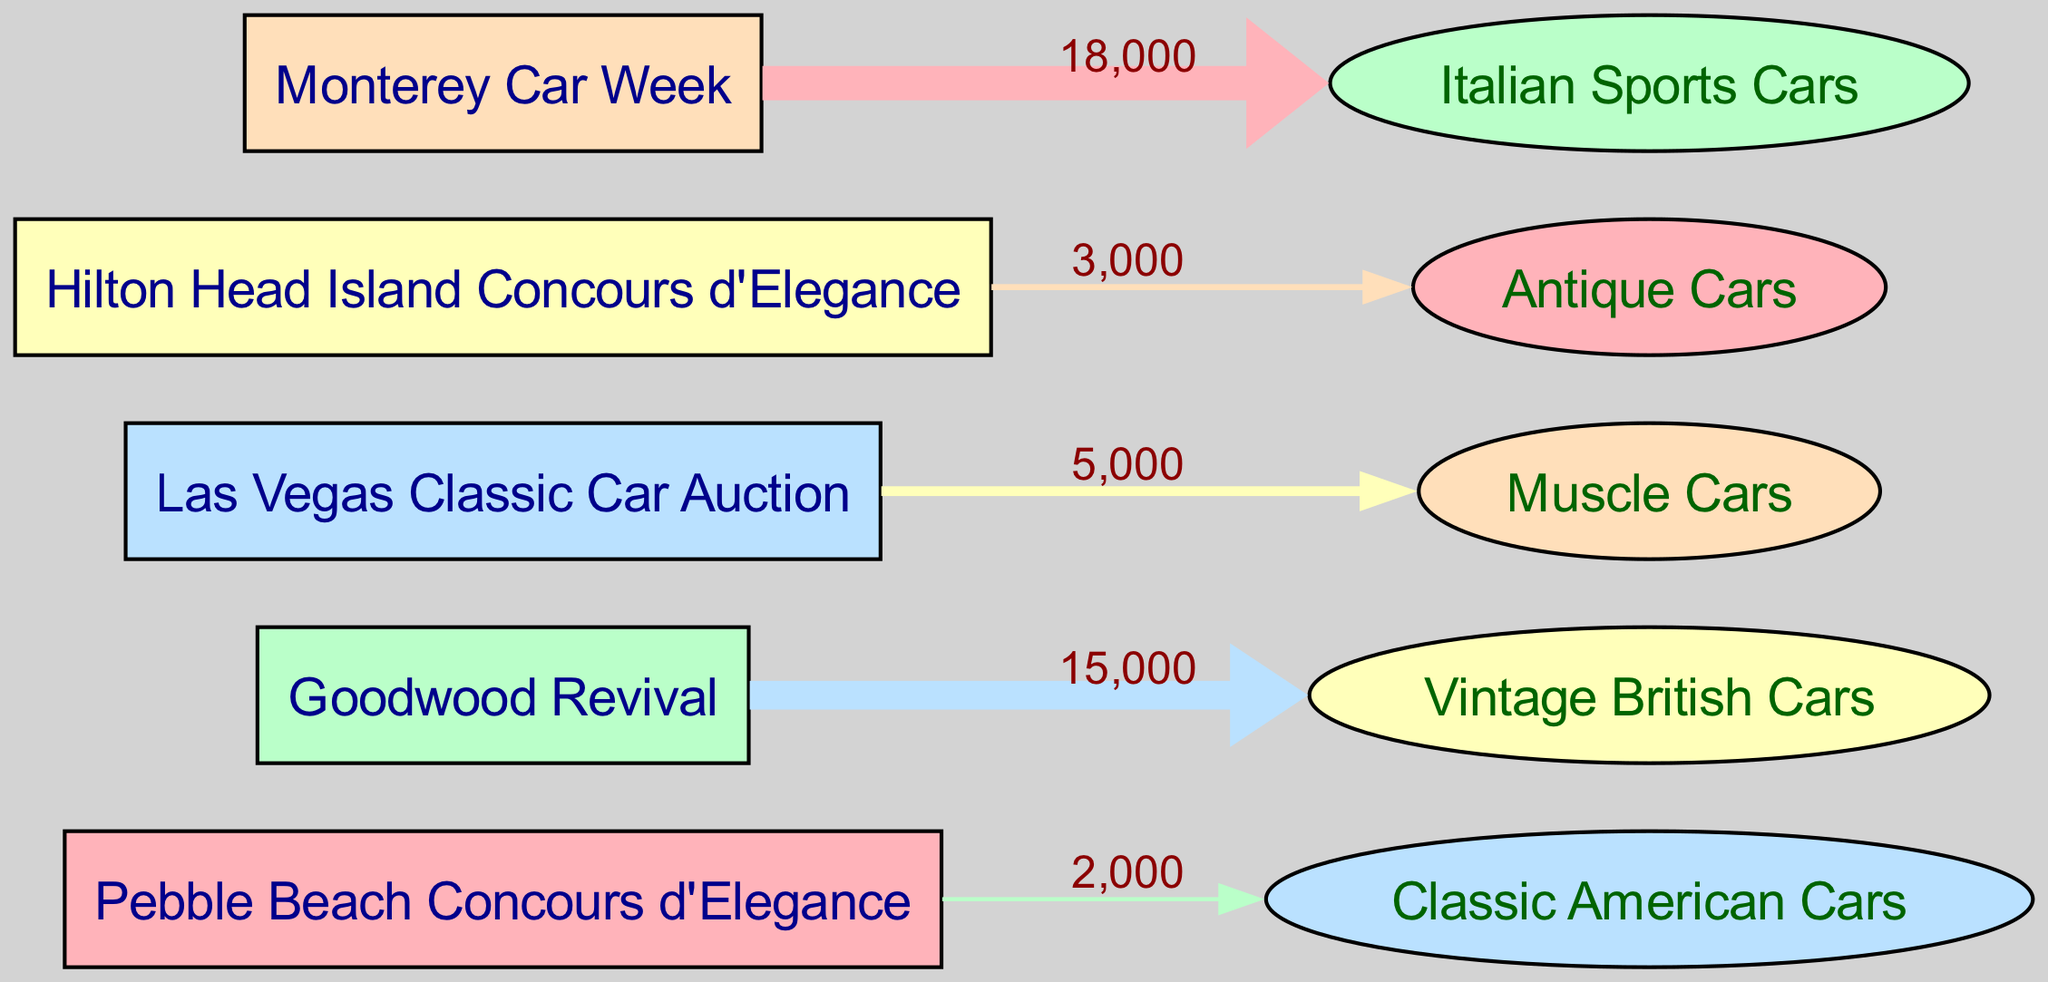What is the location with the highest visitor count? The diagram shows various car show locations and their corresponding visitor counts. By checking the flow from each location, the highest visitor count can be identified easily. In this case, "Monterey Car Week" has the highest visitor count of 18000.
Answer: Monterey Car Week How many vehicle types are represented in the diagram? The diagram includes various vehicle types connected to their respective locations. By counting the unique vehicle types shown in the diagram, we can find that there are five distinct vehicle types.
Answer: 5 What is the visitor count for the Hilton Head Island Concours d'Elegance? Each edge in the diagram carries a label indicating the visitor count from a location to a vehicle type. Looking specifically at the edge originating from "Hilton Head Island Concours d'Elegance," we see that the visitor count recorded is 3000.
Answer: 3000 Which car show has the least visitors? Upon reviewing the visitor counts connected to each car show location, we observe that "Pebble Beach Concours d'Elegance" has the lowest visitor count of 2000.
Answer: Pebble Beach Concours d'Elegance What type of vehicles is associated with the highest visitor count? By tracking the visitor counts flowing to each vehicle type in the diagram, we analyze which vehicle type corresponds with the "Monterey Car Week." Since it has the highest visitor count of 18000, we conclude that the vehicle type associated with this is "Italian Sports Cars."
Answer: Italian Sports Cars How many edges connect to the Vintage British Cars? In the diagram, each edge represents the relationship between locations and vehicle types. Here, only one location, "Goodwood Revival," connects to "Vintage British Cars," resulting in a single edge.
Answer: 1 What percentage of total visitors attended car shows featuring Muscle Cars? To answer this, we first calculate the total number of visitors across all shows, which is 2000 + 15000 + 5000 + 3000 + 18000 = 43000. Next, we note the visitor count for "Muscle Cars" is 5000. We then calculate the percentage: (5000 / 43000) * 100 ≈ 11.63%.
Answer: 11.63% 